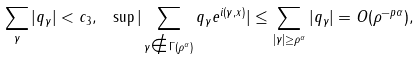Convert formula to latex. <formula><loc_0><loc_0><loc_500><loc_500>\sum _ { \gamma } | q _ { \gamma } | < c _ { 3 } , \text { } \sup | \sum _ { \gamma \notin \Gamma ( \rho ^ { \alpha } ) } q _ { \gamma } e ^ { i ( \gamma , x ) } | \leq \sum _ { | \gamma | \geq \rho ^ { \alpha } } | q _ { \gamma } | = O ( \rho ^ { - p \alpha } ) ,</formula> 